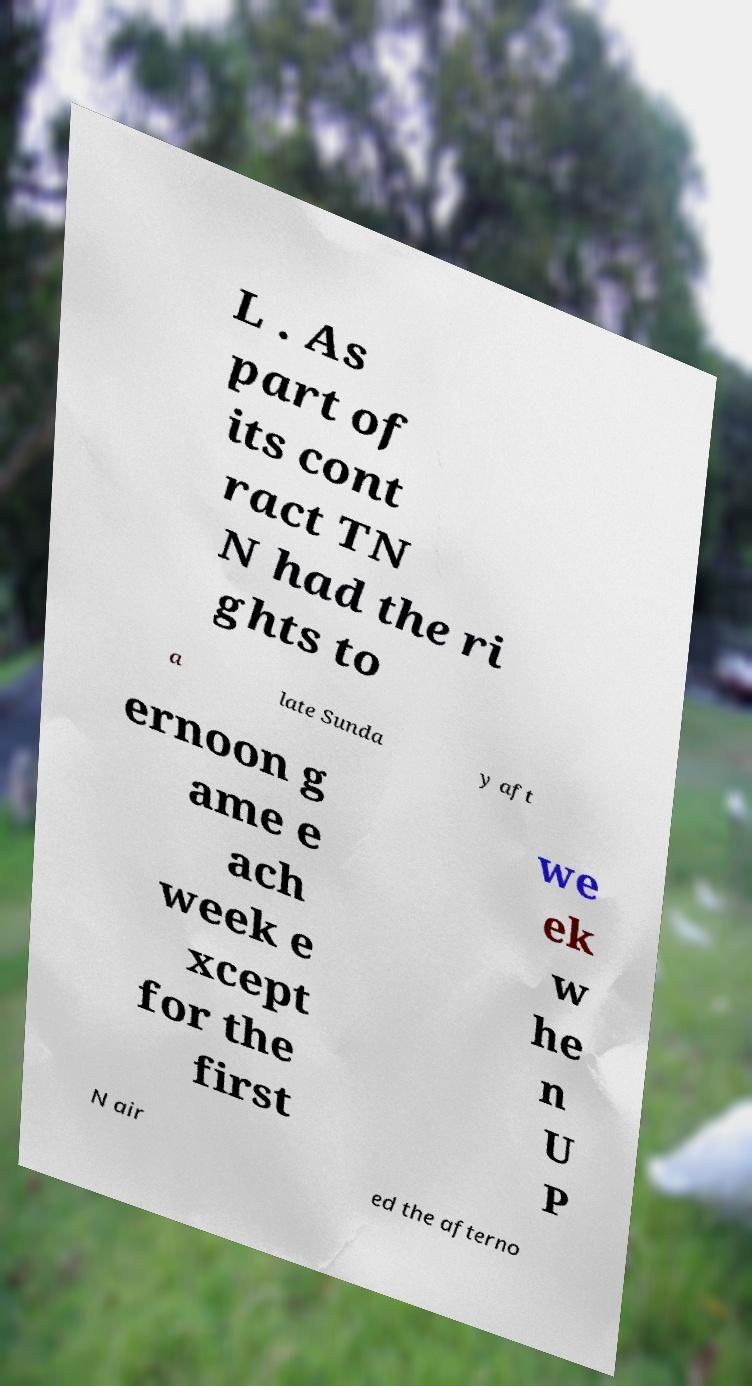Please read and relay the text visible in this image. What does it say? L . As part of its cont ract TN N had the ri ghts to a late Sunda y aft ernoon g ame e ach week e xcept for the first we ek w he n U P N air ed the afterno 